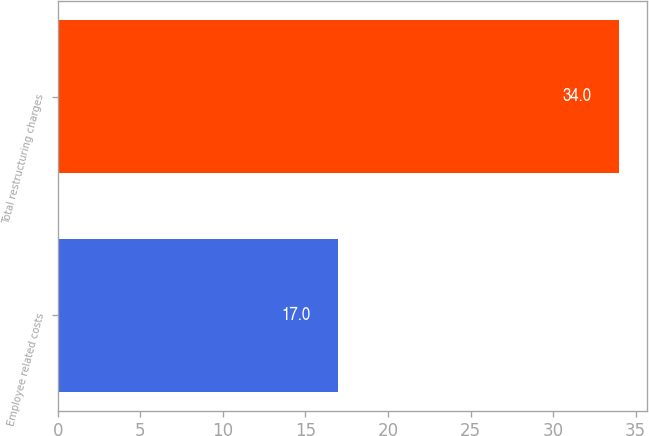Convert chart to OTSL. <chart><loc_0><loc_0><loc_500><loc_500><bar_chart><fcel>Employee related costs<fcel>Total restructuring charges<nl><fcel>17<fcel>34<nl></chart> 